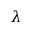Convert formula to latex. <formula><loc_0><loc_0><loc_500><loc_500>\lambda</formula> 